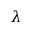Convert formula to latex. <formula><loc_0><loc_0><loc_500><loc_500>\lambda</formula> 